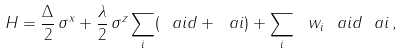Convert formula to latex. <formula><loc_0><loc_0><loc_500><loc_500>H = \frac { \Delta } { 2 } \, \sigma ^ { x } + \frac { \lambda } { 2 } \, \sigma ^ { z } \sum _ { i } ( \ a i d + \ a i ) + \sum _ { i } \ w _ { i } \ a i d \ a i \, ,</formula> 